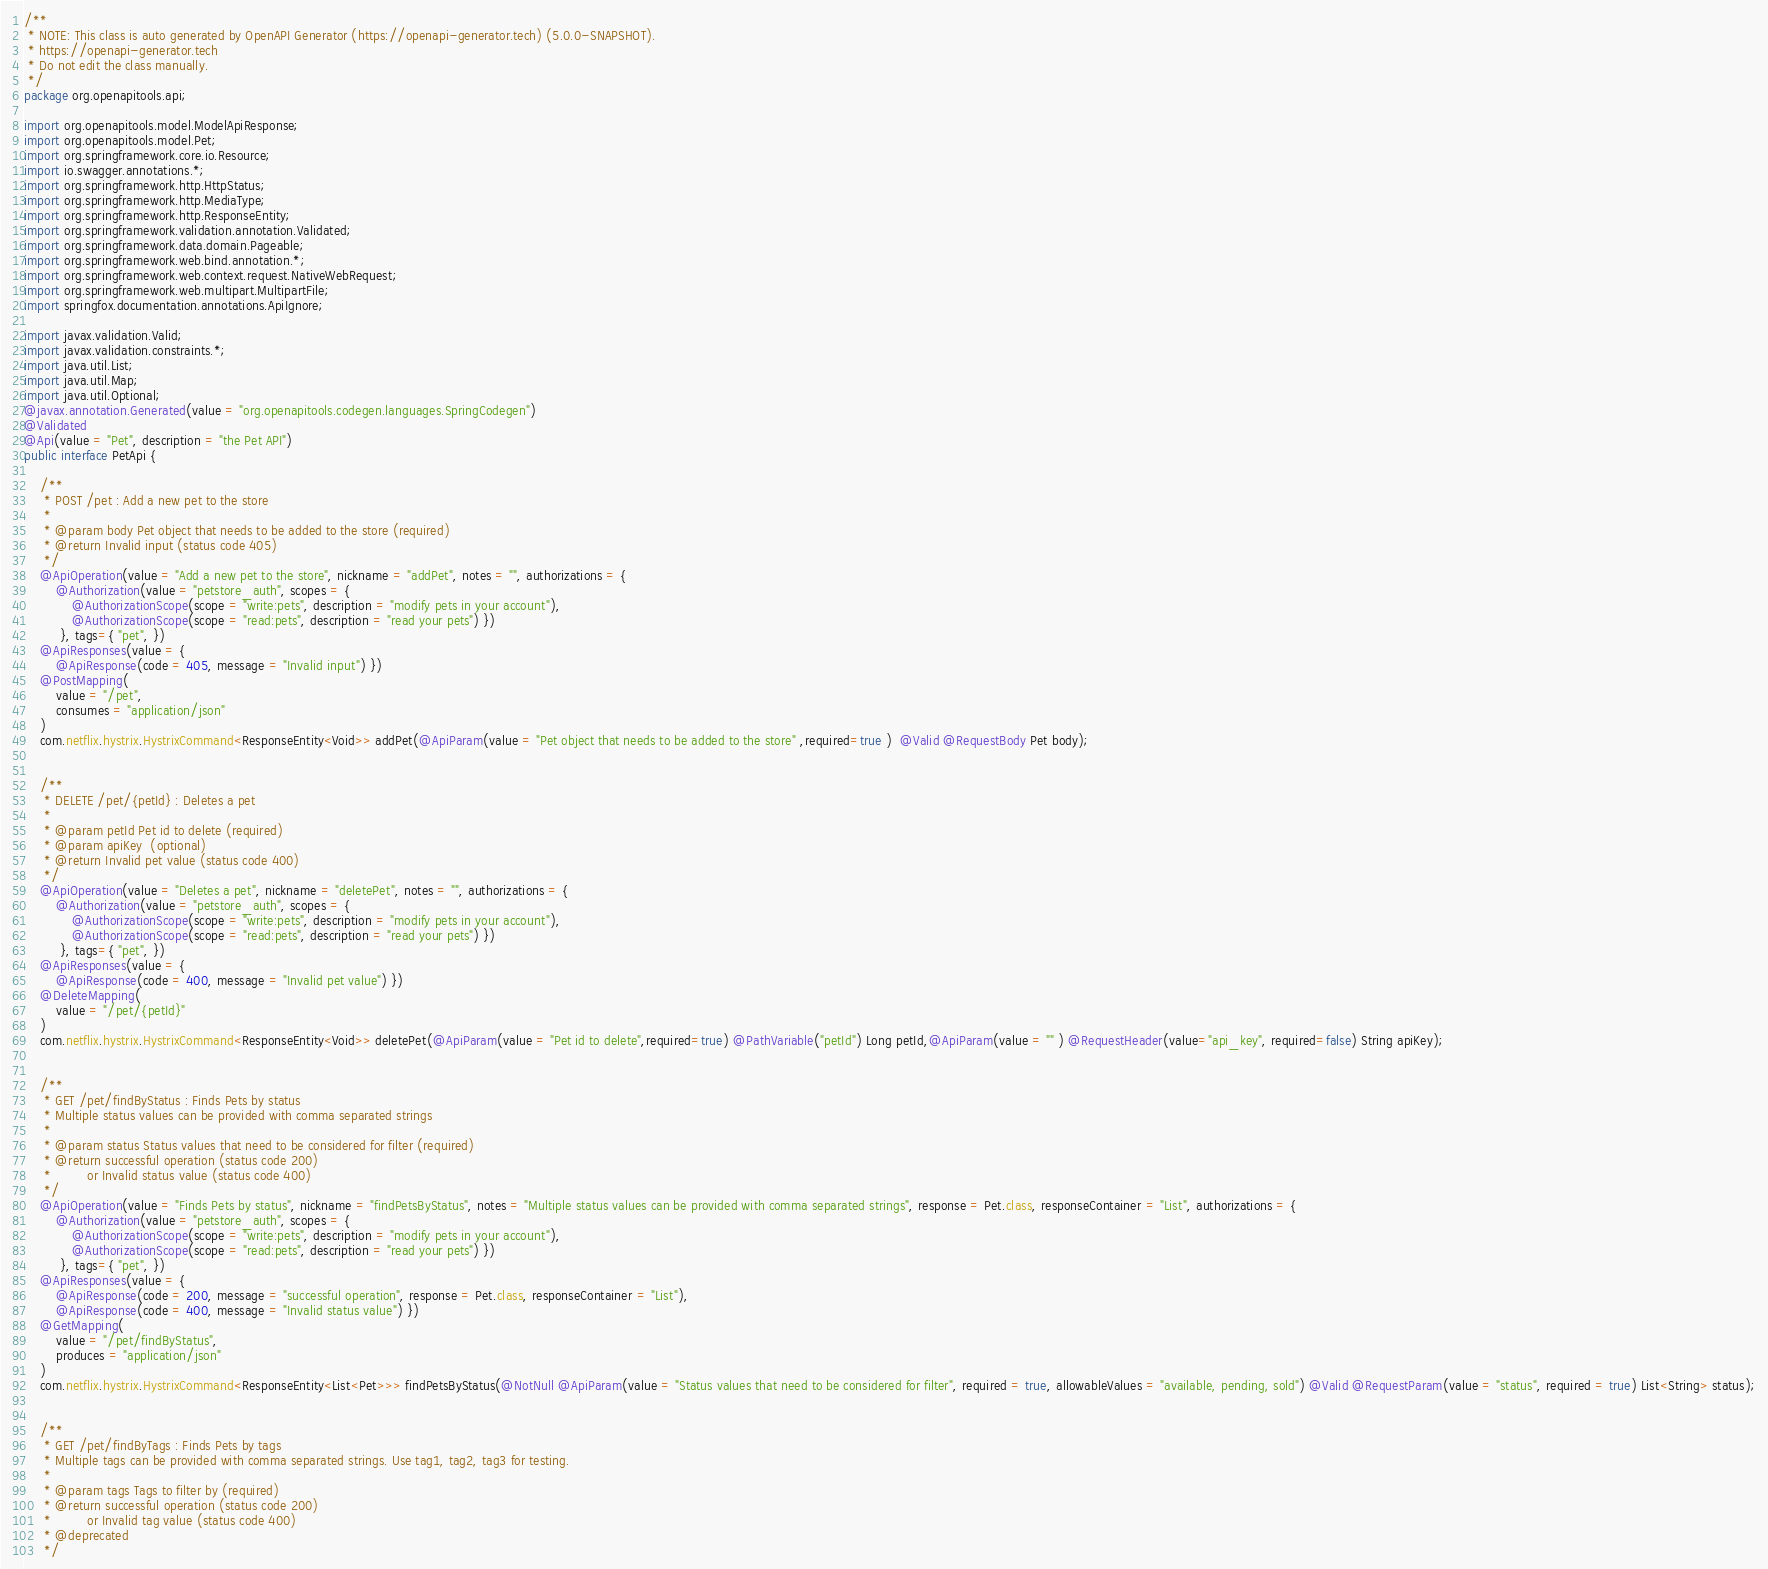Convert code to text. <code><loc_0><loc_0><loc_500><loc_500><_Java_>/**
 * NOTE: This class is auto generated by OpenAPI Generator (https://openapi-generator.tech) (5.0.0-SNAPSHOT).
 * https://openapi-generator.tech
 * Do not edit the class manually.
 */
package org.openapitools.api;

import org.openapitools.model.ModelApiResponse;
import org.openapitools.model.Pet;
import org.springframework.core.io.Resource;
import io.swagger.annotations.*;
import org.springframework.http.HttpStatus;
import org.springframework.http.MediaType;
import org.springframework.http.ResponseEntity;
import org.springframework.validation.annotation.Validated;
import org.springframework.data.domain.Pageable;
import org.springframework.web.bind.annotation.*;
import org.springframework.web.context.request.NativeWebRequest;
import org.springframework.web.multipart.MultipartFile;
import springfox.documentation.annotations.ApiIgnore;

import javax.validation.Valid;
import javax.validation.constraints.*;
import java.util.List;
import java.util.Map;
import java.util.Optional;
@javax.annotation.Generated(value = "org.openapitools.codegen.languages.SpringCodegen")
@Validated
@Api(value = "Pet", description = "the Pet API")
public interface PetApi {

    /**
     * POST /pet : Add a new pet to the store
     *
     * @param body Pet object that needs to be added to the store (required)
     * @return Invalid input (status code 405)
     */
    @ApiOperation(value = "Add a new pet to the store", nickname = "addPet", notes = "", authorizations = {
        @Authorization(value = "petstore_auth", scopes = {
            @AuthorizationScope(scope = "write:pets", description = "modify pets in your account"),
            @AuthorizationScope(scope = "read:pets", description = "read your pets") })
         }, tags={ "pet", })
    @ApiResponses(value = { 
        @ApiResponse(code = 405, message = "Invalid input") })
    @PostMapping(
        value = "/pet",
        consumes = "application/json"
    )
    com.netflix.hystrix.HystrixCommand<ResponseEntity<Void>> addPet(@ApiParam(value = "Pet object that needs to be added to the store" ,required=true )  @Valid @RequestBody Pet body);


    /**
     * DELETE /pet/{petId} : Deletes a pet
     *
     * @param petId Pet id to delete (required)
     * @param apiKey  (optional)
     * @return Invalid pet value (status code 400)
     */
    @ApiOperation(value = "Deletes a pet", nickname = "deletePet", notes = "", authorizations = {
        @Authorization(value = "petstore_auth", scopes = {
            @AuthorizationScope(scope = "write:pets", description = "modify pets in your account"),
            @AuthorizationScope(scope = "read:pets", description = "read your pets") })
         }, tags={ "pet", })
    @ApiResponses(value = { 
        @ApiResponse(code = 400, message = "Invalid pet value") })
    @DeleteMapping(
        value = "/pet/{petId}"
    )
    com.netflix.hystrix.HystrixCommand<ResponseEntity<Void>> deletePet(@ApiParam(value = "Pet id to delete",required=true) @PathVariable("petId") Long petId,@ApiParam(value = "" ) @RequestHeader(value="api_key", required=false) String apiKey);


    /**
     * GET /pet/findByStatus : Finds Pets by status
     * Multiple status values can be provided with comma separated strings
     *
     * @param status Status values that need to be considered for filter (required)
     * @return successful operation (status code 200)
     *         or Invalid status value (status code 400)
     */
    @ApiOperation(value = "Finds Pets by status", nickname = "findPetsByStatus", notes = "Multiple status values can be provided with comma separated strings", response = Pet.class, responseContainer = "List", authorizations = {
        @Authorization(value = "petstore_auth", scopes = {
            @AuthorizationScope(scope = "write:pets", description = "modify pets in your account"),
            @AuthorizationScope(scope = "read:pets", description = "read your pets") })
         }, tags={ "pet", })
    @ApiResponses(value = { 
        @ApiResponse(code = 200, message = "successful operation", response = Pet.class, responseContainer = "List"),
        @ApiResponse(code = 400, message = "Invalid status value") })
    @GetMapping(
        value = "/pet/findByStatus",
        produces = "application/json"
    )
    com.netflix.hystrix.HystrixCommand<ResponseEntity<List<Pet>>> findPetsByStatus(@NotNull @ApiParam(value = "Status values that need to be considered for filter", required = true, allowableValues = "available, pending, sold") @Valid @RequestParam(value = "status", required = true) List<String> status);


    /**
     * GET /pet/findByTags : Finds Pets by tags
     * Multiple tags can be provided with comma separated strings. Use tag1, tag2, tag3 for testing.
     *
     * @param tags Tags to filter by (required)
     * @return successful operation (status code 200)
     *         or Invalid tag value (status code 400)
     * @deprecated
     */</code> 